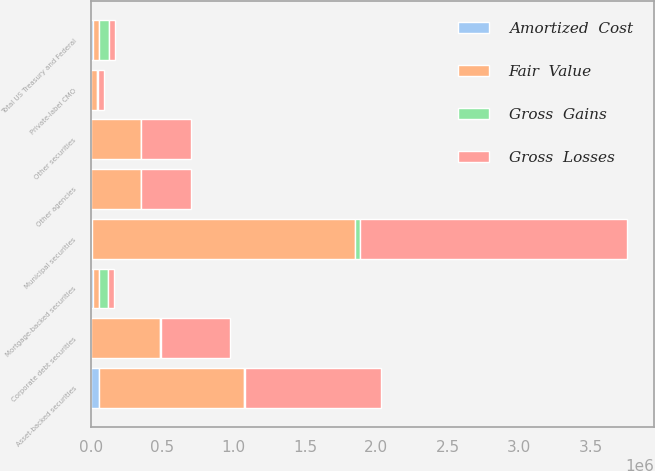<chart> <loc_0><loc_0><loc_500><loc_500><stacked_bar_chart><ecel><fcel>Mortgage-backed securities<fcel>Other agencies<fcel>Total US Treasury and Federal<fcel>Municipal securities<fcel>Private-label CMO<fcel>Asset-backed securities<fcel>Corporate debt securities<fcel>Other securities<nl><fcel>Fair  Value<fcel>42828<fcel>349715<fcel>42828<fcel>1.84131e+06<fcel>43730<fcel>1.015e+06<fcel>479151<fcel>351646<nl><fcel>Gross  Gains<fcel>63906<fcel>2871<fcel>66794<fcel>37398<fcel>1116<fcel>2061<fcel>9442<fcel>743<nl><fcel>Amortized  Cost<fcel>15104<fcel>1043<fcel>16147<fcel>10140<fcel>2920<fcel>61062<fcel>2417<fcel>84<nl><fcel>Gross  Losses<fcel>42828<fcel>351543<fcel>42828<fcel>1.86857e+06<fcel>41926<fcel>955998<fcel>486176<fcel>352305<nl></chart> 